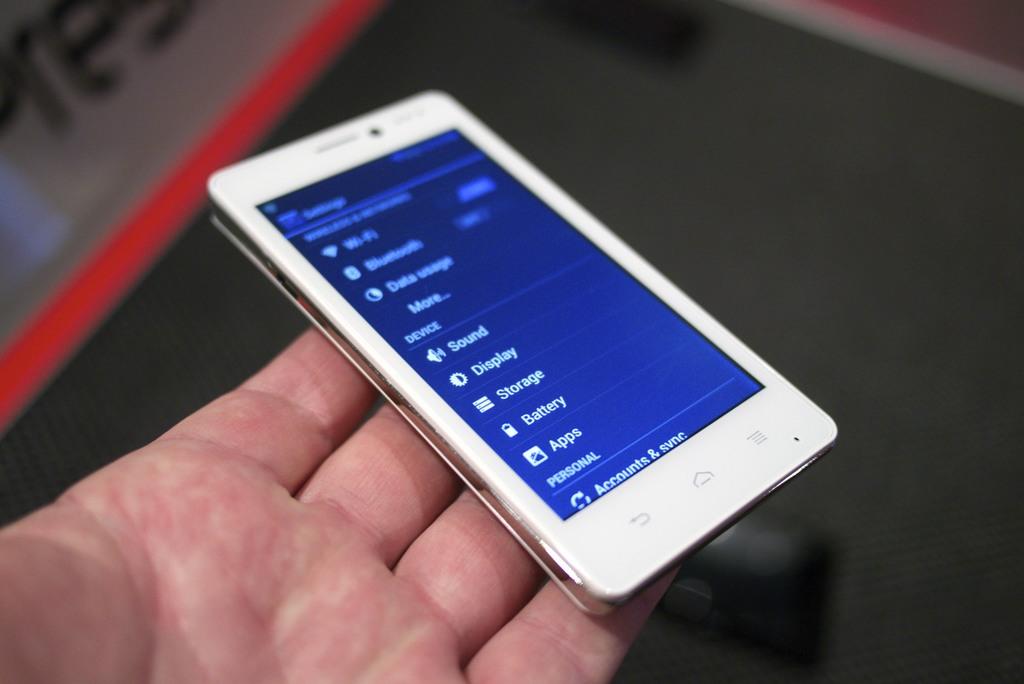What is one of the options seen on the phone?
Your answer should be compact. Apps. 